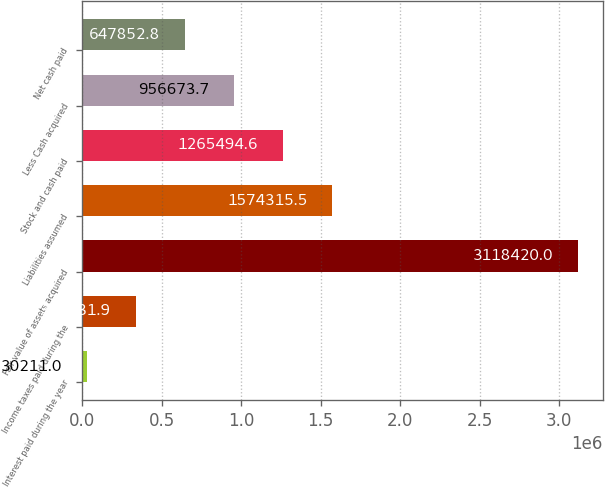Convert chart. <chart><loc_0><loc_0><loc_500><loc_500><bar_chart><fcel>Interest paid during the year<fcel>Income taxes paid during the<fcel>Fair value of assets acquired<fcel>Liabilities assumed<fcel>Stock and cash paid<fcel>Less Cash acquired<fcel>Net cash paid<nl><fcel>30211<fcel>339032<fcel>3.11842e+06<fcel>1.57432e+06<fcel>1.26549e+06<fcel>956674<fcel>647853<nl></chart> 